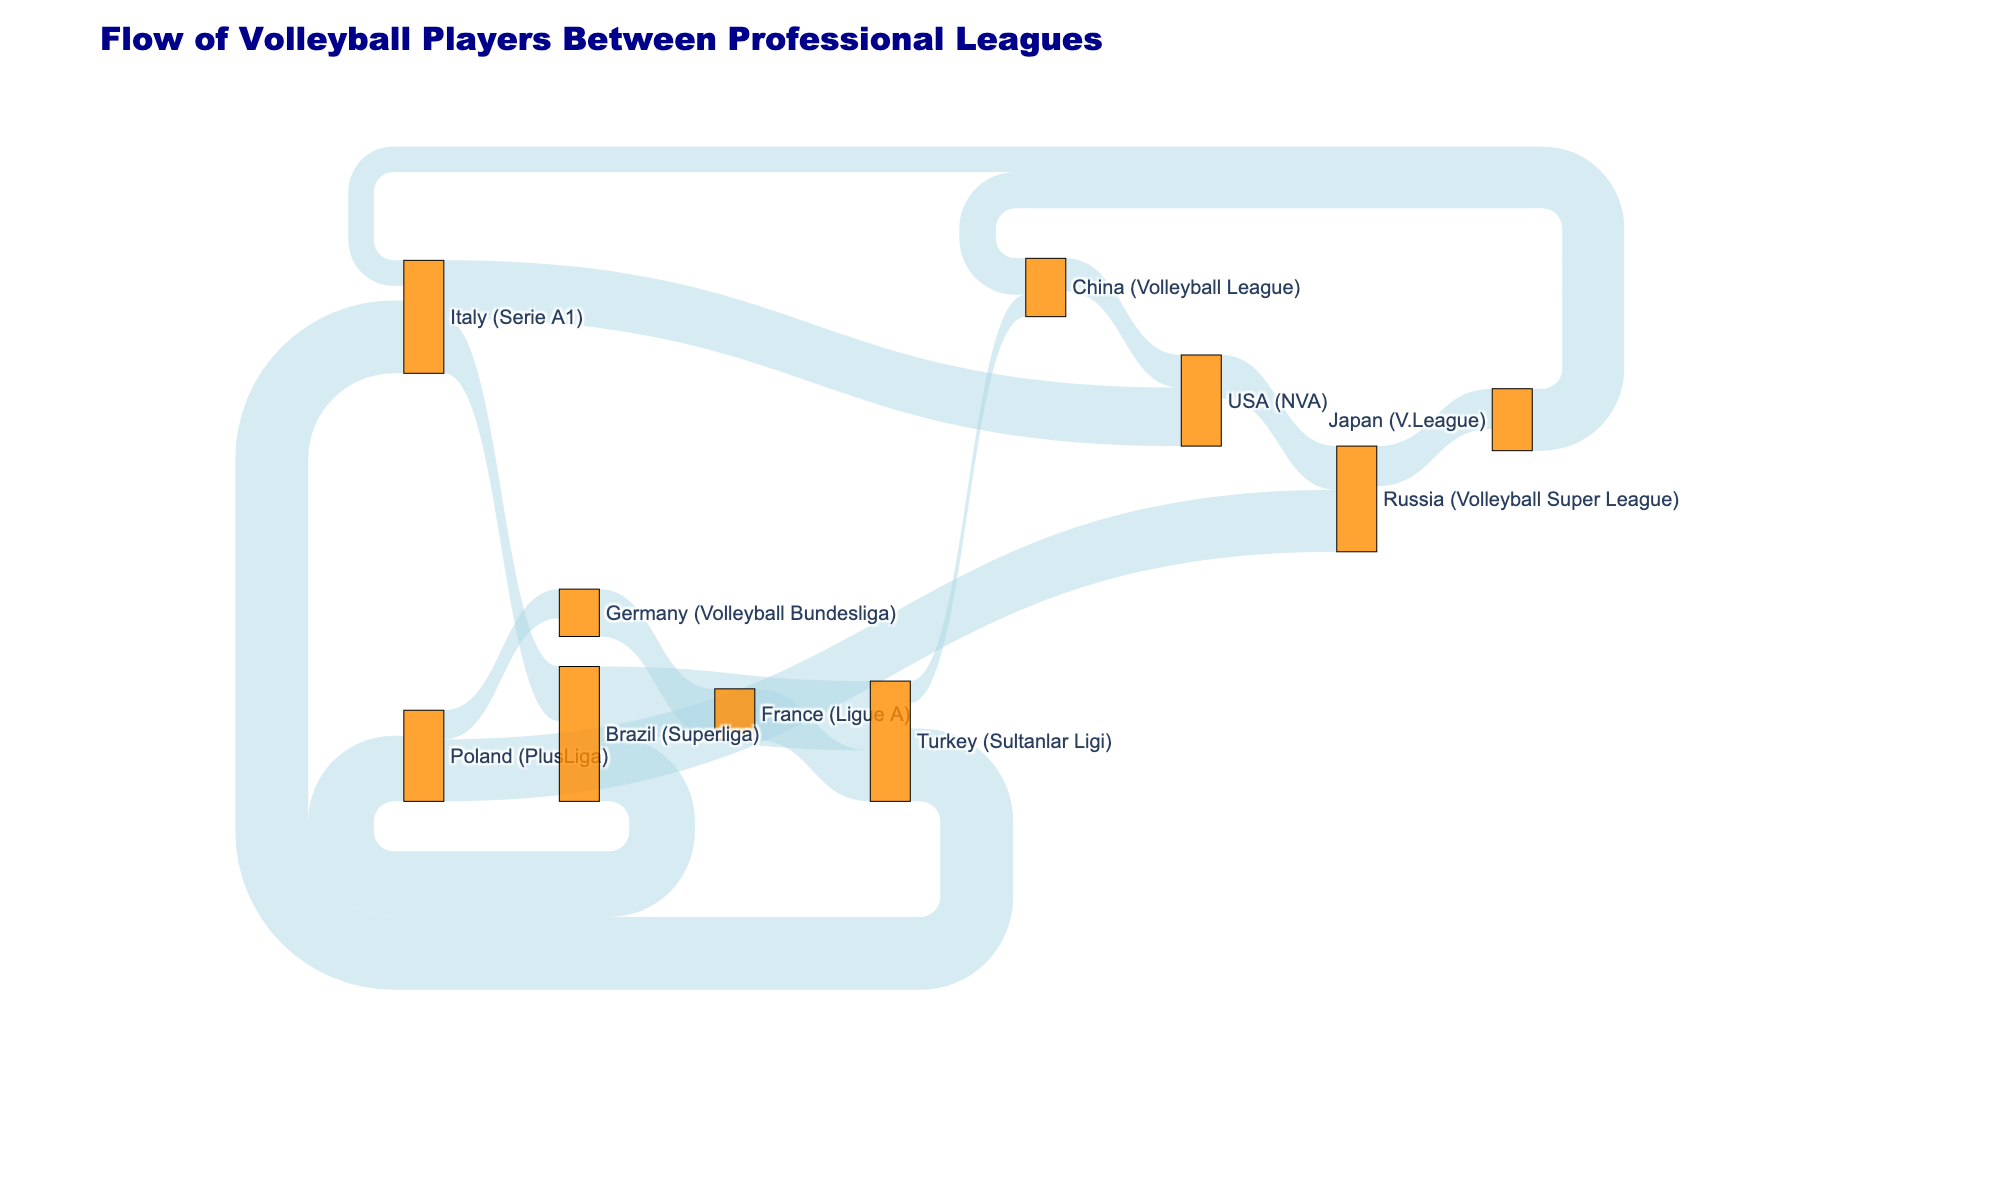What's the title of the figure? The title of the figure is written at the top of the diagram, indicating the overall subject or theme of the data visualization.
Answer: Flow of Volleyball Players Between Professional Leagues How many unique leagues are involved in the diagram? Count all distinct labels (leagues) on both nodes (squares) representing unique volleyball leagues.
Answer: 12 Which league sends the most players to another league, and how many? By comparing the values of outgoing flows from each league (source), identify the highest value representing the league sending the most players.
Answer: Turkey (Sultanlar Ligi), 20 What is the value of players moving from Brazil (Superliga) to Poland (PlusLiga)? Trace the flow from Brazil (Superliga) to Poland (PlusLiga) and check the connecting line's value.
Answer: 18 What's the difference in the number of players moving from USA (NVA) to Russia (Volleyball Super League) and the number moving from USA (NVA) to Italy (Serie A1)? Subtract the number of players moving from USA (NVA) to Italy (Serie A1) from those moving from USA (NVA) to Russia (Volleyball Super League).
Answer: 12 - 16 = -4 (4 more players move to Italy (Serie A1)) Which league receives the most players from another league, and how many? By comparing the values of incoming flows to each league (target), identify the highest value representing the league receiving the most players.
Answer: Italy (Serie A1), 20 Are there more players moving from Brazil (Superliga) to Turkey (Sultanlar Ligi) or Russia (Volleyball Super League) to Japan (V.League)? Compare the values of the flows between Brazil (Superliga) to Turkey (Sultanlar Ligi) and Russia (Volleyball Super League) to Japan (V.League).
Answer: Brazil (Superliga) to Turkey (Sultanlar Ligi), 19 Which leagues have a value of exactly 10 players moving between them? Find the connection (link) with the value of 10 and identify the corresponding source and target leagues.
Answer: Japan (V.League) to China (Volleyball League) How many players move from leagues in Europe to leagues in Asia? Sum the values of flows moving from any league in Europe (Italy, Poland, Germany, France, Turkey, Russia) to any league in Asia (Japan, China).
Answer: 6 (Turkey to China) + 11 (Russia to Japan) = 17 What's the net flow of players into the USA (NVA) league? Calculate the difference between the total number of players coming into USA (NVA) and those leaving. Sum values of incoming and outgoing flows for USA (NVA) and find the difference.
Answer: (9 + 16) - 12 = 13 